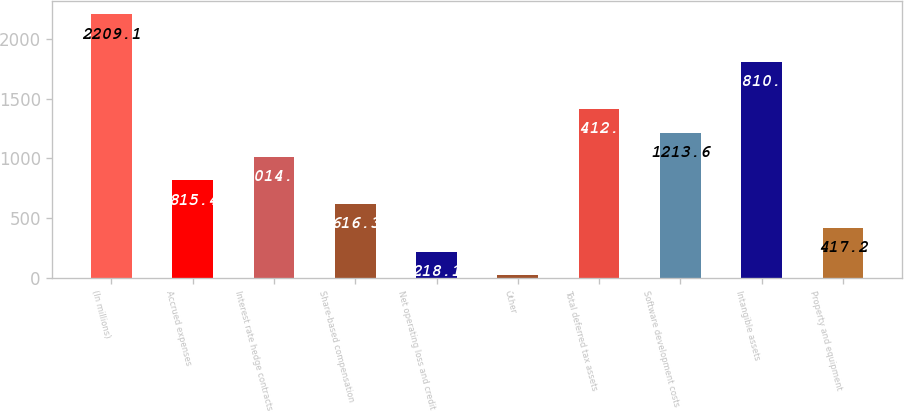Convert chart to OTSL. <chart><loc_0><loc_0><loc_500><loc_500><bar_chart><fcel>(In millions)<fcel>Accrued expenses<fcel>Interest rate hedge contracts<fcel>Share-based compensation<fcel>Net operating loss and credit<fcel>Other<fcel>Total deferred tax assets<fcel>Software development costs<fcel>Intangible assets<fcel>Property and equipment<nl><fcel>2209.1<fcel>815.4<fcel>1014.5<fcel>616.3<fcel>218.1<fcel>19<fcel>1412.7<fcel>1213.6<fcel>1810.9<fcel>417.2<nl></chart> 